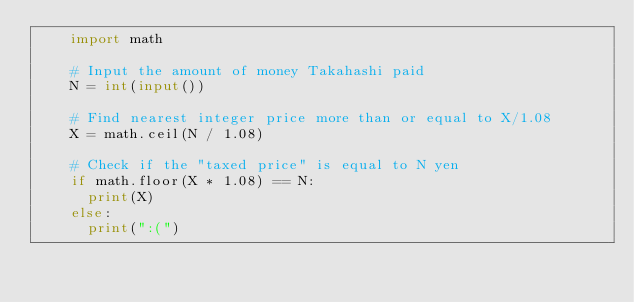Convert code to text. <code><loc_0><loc_0><loc_500><loc_500><_Python_>    import math
     
    # Input the amount of money Takahashi paid
    N = int(input())
     
    # Find nearest integer price more than or equal to X/1.08
    X = math.ceil(N / 1.08)
     
    # Check if the "taxed price" is equal to N yen
    if math.floor(X * 1.08) == N:
    	print(X)
    else:
    	print(":(")</code> 